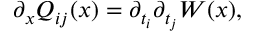<formula> <loc_0><loc_0><loc_500><loc_500>\partial _ { x } Q _ { i j } ( x ) = \partial _ { t _ { i } } \partial _ { t _ { j } } W ( x ) ,</formula> 